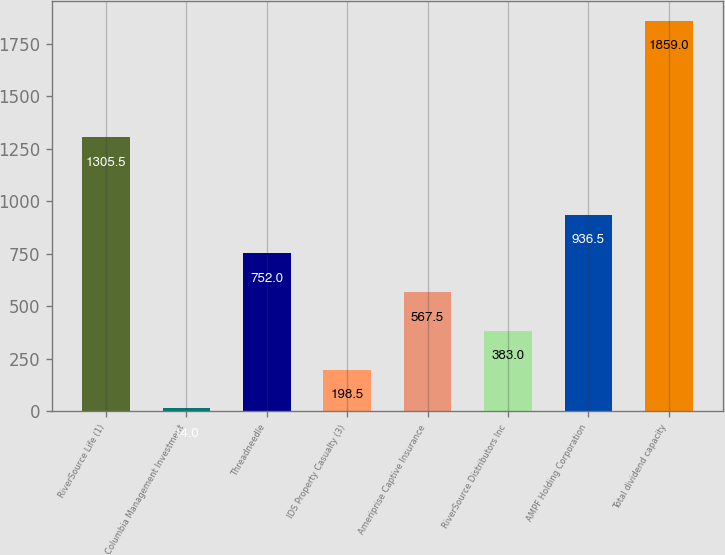Convert chart. <chart><loc_0><loc_0><loc_500><loc_500><bar_chart><fcel>RiverSource Life (1)<fcel>Columbia Management Investment<fcel>Threadneedle<fcel>IDS Property Casualty (3)<fcel>Ameriprise Captive Insurance<fcel>RiverSource Distributors Inc<fcel>AMPF Holding Corporation<fcel>Total dividend capacity<nl><fcel>1305.5<fcel>14<fcel>752<fcel>198.5<fcel>567.5<fcel>383<fcel>936.5<fcel>1859<nl></chart> 